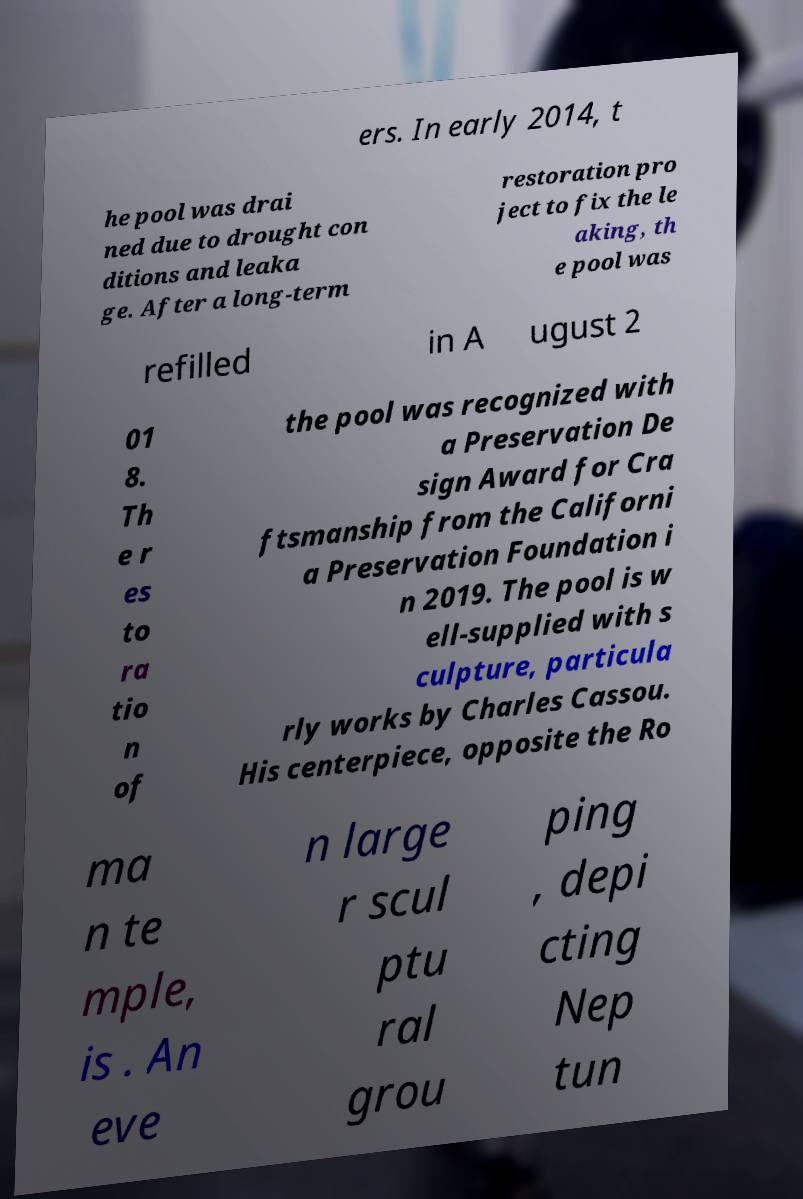Could you assist in decoding the text presented in this image and type it out clearly? ers. In early 2014, t he pool was drai ned due to drought con ditions and leaka ge. After a long-term restoration pro ject to fix the le aking, th e pool was refilled in A ugust 2 01 8. Th e r es to ra tio n of the pool was recognized with a Preservation De sign Award for Cra ftsmanship from the Californi a Preservation Foundation i n 2019. The pool is w ell-supplied with s culpture, particula rly works by Charles Cassou. His centerpiece, opposite the Ro ma n te mple, is . An eve n large r scul ptu ral grou ping , depi cting Nep tun 